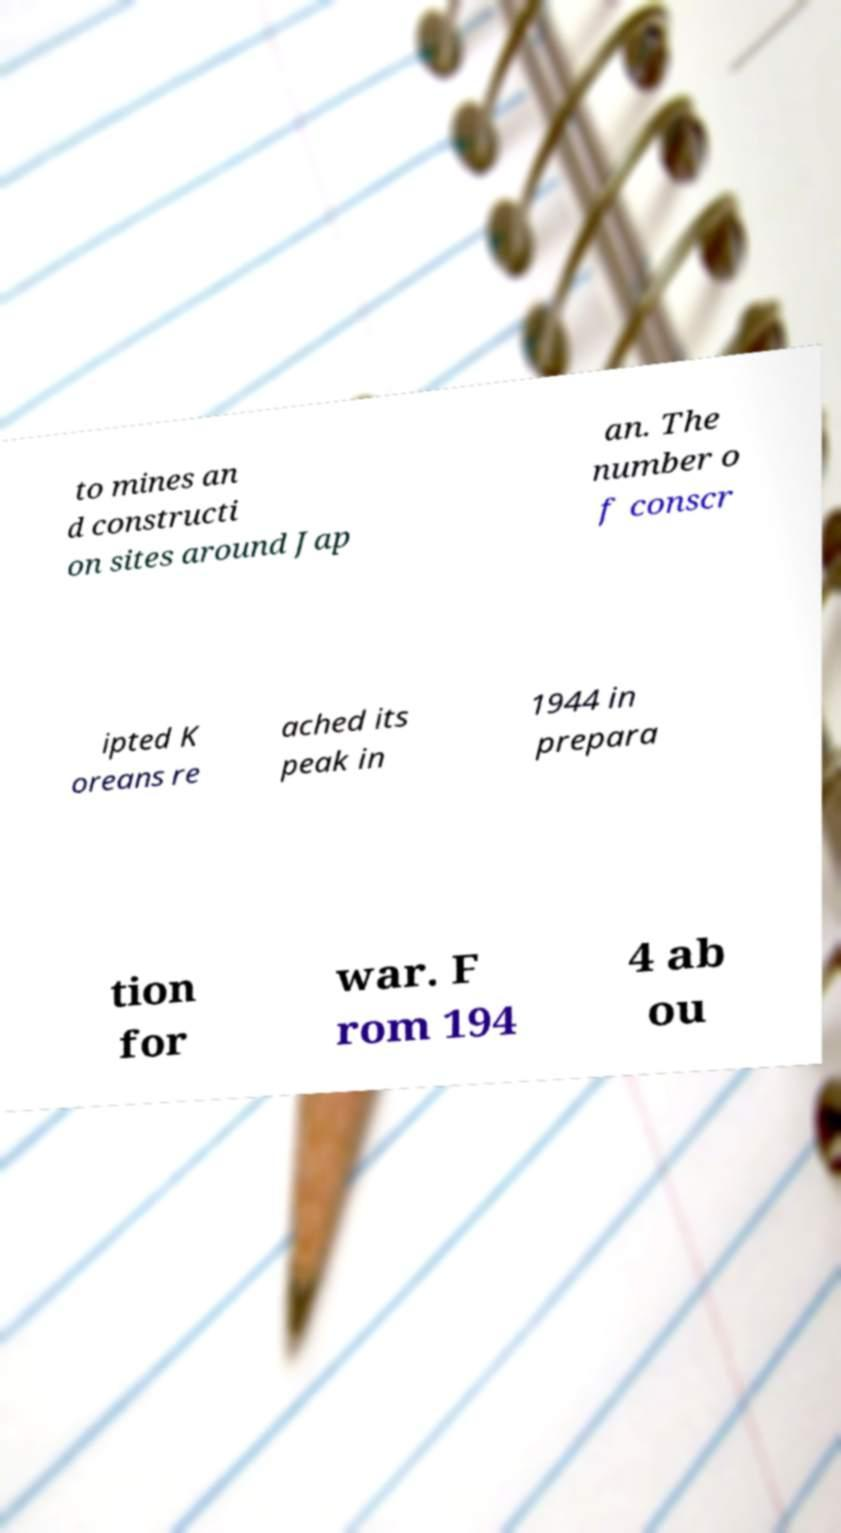Could you assist in decoding the text presented in this image and type it out clearly? to mines an d constructi on sites around Jap an. The number o f conscr ipted K oreans re ached its peak in 1944 in prepara tion for war. F rom 194 4 ab ou 